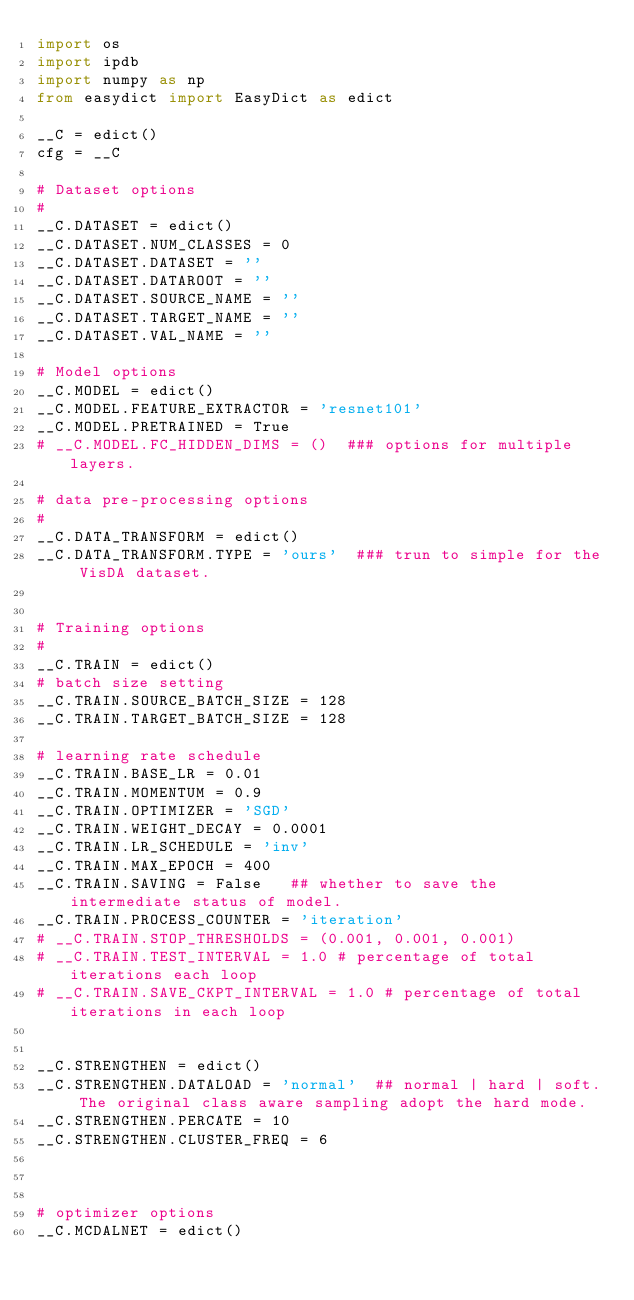<code> <loc_0><loc_0><loc_500><loc_500><_Python_>import os
import ipdb
import numpy as np
from easydict import EasyDict as edict

__C = edict()
cfg = __C

# Dataset options
#
__C.DATASET = edict()
__C.DATASET.NUM_CLASSES = 0
__C.DATASET.DATASET = ''
__C.DATASET.DATAROOT = ''
__C.DATASET.SOURCE_NAME = ''
__C.DATASET.TARGET_NAME = ''
__C.DATASET.VAL_NAME = ''

# Model options
__C.MODEL = edict()
__C.MODEL.FEATURE_EXTRACTOR = 'resnet101'
__C.MODEL.PRETRAINED = True
# __C.MODEL.FC_HIDDEN_DIMS = ()  ### options for multiple layers.

# data pre-processing options
#
__C.DATA_TRANSFORM = edict()
__C.DATA_TRANSFORM.TYPE = 'ours'  ### trun to simple for the VisDA dataset.


# Training options
#
__C.TRAIN = edict()
# batch size setting
__C.TRAIN.SOURCE_BATCH_SIZE = 128
__C.TRAIN.TARGET_BATCH_SIZE = 128

# learning rate schedule
__C.TRAIN.BASE_LR = 0.01
__C.TRAIN.MOMENTUM = 0.9
__C.TRAIN.OPTIMIZER = 'SGD'
__C.TRAIN.WEIGHT_DECAY = 0.0001
__C.TRAIN.LR_SCHEDULE = 'inv'
__C.TRAIN.MAX_EPOCH = 400
__C.TRAIN.SAVING = False   ## whether to save the intermediate status of model.
__C.TRAIN.PROCESS_COUNTER = 'iteration'
# __C.TRAIN.STOP_THRESHOLDS = (0.001, 0.001, 0.001)
# __C.TRAIN.TEST_INTERVAL = 1.0 # percentage of total iterations each loop
# __C.TRAIN.SAVE_CKPT_INTERVAL = 1.0 # percentage of total iterations in each loop


__C.STRENGTHEN = edict()
__C.STRENGTHEN.DATALOAD = 'normal'  ## normal | hard | soft. The original class aware sampling adopt the hard mode.
__C.STRENGTHEN.PERCATE = 10
__C.STRENGTHEN.CLUSTER_FREQ = 6



# optimizer options
__C.MCDALNET = edict()</code> 